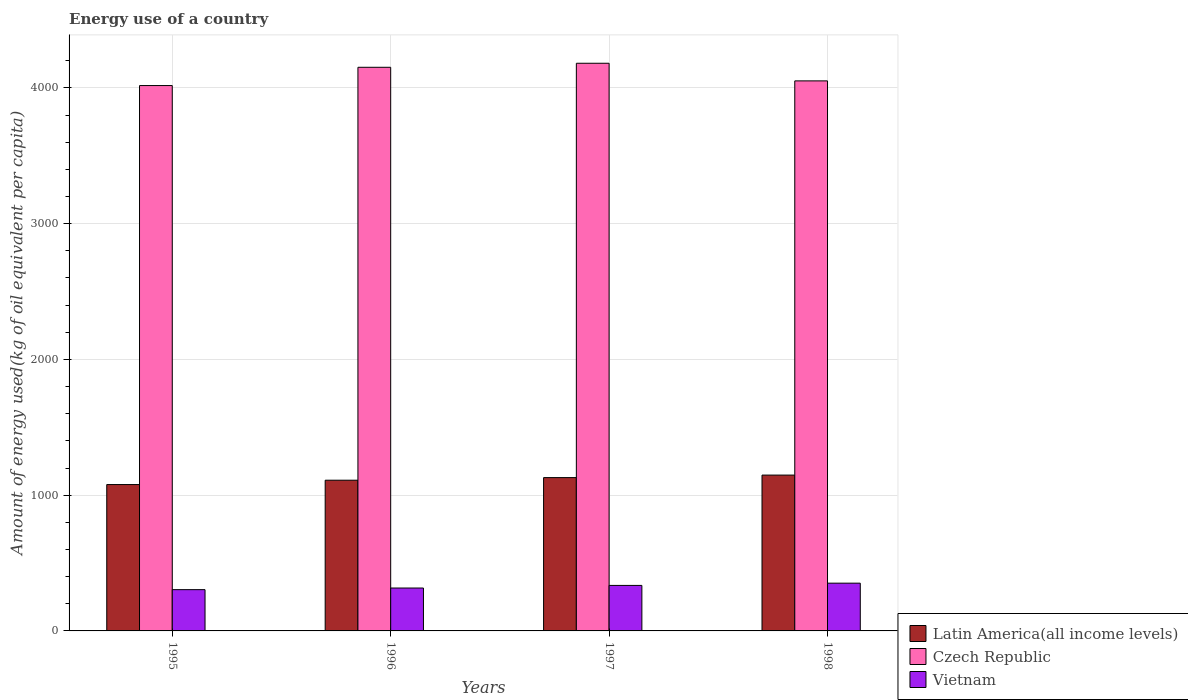How many different coloured bars are there?
Offer a very short reply. 3. Are the number of bars on each tick of the X-axis equal?
Make the answer very short. Yes. What is the label of the 4th group of bars from the left?
Keep it short and to the point. 1998. In how many cases, is the number of bars for a given year not equal to the number of legend labels?
Give a very brief answer. 0. What is the amount of energy used in in Latin America(all income levels) in 1996?
Give a very brief answer. 1110.09. Across all years, what is the maximum amount of energy used in in Czech Republic?
Provide a succinct answer. 4181.19. Across all years, what is the minimum amount of energy used in in Latin America(all income levels)?
Offer a very short reply. 1078.08. In which year was the amount of energy used in in Czech Republic maximum?
Keep it short and to the point. 1997. What is the total amount of energy used in in Vietnam in the graph?
Provide a short and direct response. 1306.82. What is the difference between the amount of energy used in in Vietnam in 1996 and that in 1998?
Give a very brief answer. -35.82. What is the difference between the amount of energy used in in Czech Republic in 1997 and the amount of energy used in in Latin America(all income levels) in 1996?
Provide a short and direct response. 3071.1. What is the average amount of energy used in in Czech Republic per year?
Ensure brevity in your answer.  4100.27. In the year 1996, what is the difference between the amount of energy used in in Vietnam and amount of energy used in in Latin America(all income levels)?
Provide a succinct answer. -794.17. What is the ratio of the amount of energy used in in Latin America(all income levels) in 1996 to that in 1997?
Your answer should be compact. 0.98. Is the amount of energy used in in Vietnam in 1997 less than that in 1998?
Make the answer very short. Yes. Is the difference between the amount of energy used in in Vietnam in 1995 and 1998 greater than the difference between the amount of energy used in in Latin America(all income levels) in 1995 and 1998?
Ensure brevity in your answer.  Yes. What is the difference between the highest and the second highest amount of energy used in in Vietnam?
Ensure brevity in your answer.  16.57. What is the difference between the highest and the lowest amount of energy used in in Czech Republic?
Your answer should be very brief. 164.22. Is the sum of the amount of energy used in in Czech Republic in 1995 and 1997 greater than the maximum amount of energy used in in Vietnam across all years?
Offer a terse response. Yes. What does the 1st bar from the left in 1997 represents?
Ensure brevity in your answer.  Latin America(all income levels). What does the 1st bar from the right in 1997 represents?
Your response must be concise. Vietnam. Are all the bars in the graph horizontal?
Ensure brevity in your answer.  No. How many years are there in the graph?
Your answer should be compact. 4. Are the values on the major ticks of Y-axis written in scientific E-notation?
Keep it short and to the point. No. Does the graph contain grids?
Ensure brevity in your answer.  Yes. Where does the legend appear in the graph?
Offer a very short reply. Bottom right. How many legend labels are there?
Make the answer very short. 3. What is the title of the graph?
Your answer should be very brief. Energy use of a country. Does "Latvia" appear as one of the legend labels in the graph?
Make the answer very short. No. What is the label or title of the Y-axis?
Offer a very short reply. Amount of energy used(kg of oil equivalent per capita). What is the Amount of energy used(kg of oil equivalent per capita) in Latin America(all income levels) in 1995?
Provide a short and direct response. 1078.08. What is the Amount of energy used(kg of oil equivalent per capita) of Czech Republic in 1995?
Give a very brief answer. 4016.97. What is the Amount of energy used(kg of oil equivalent per capita) of Vietnam in 1995?
Provide a succinct answer. 303.98. What is the Amount of energy used(kg of oil equivalent per capita) in Latin America(all income levels) in 1996?
Offer a very short reply. 1110.09. What is the Amount of energy used(kg of oil equivalent per capita) in Czech Republic in 1996?
Offer a terse response. 4151.5. What is the Amount of energy used(kg of oil equivalent per capita) of Vietnam in 1996?
Your answer should be very brief. 315.93. What is the Amount of energy used(kg of oil equivalent per capita) in Latin America(all income levels) in 1997?
Offer a very short reply. 1129.26. What is the Amount of energy used(kg of oil equivalent per capita) of Czech Republic in 1997?
Offer a very short reply. 4181.19. What is the Amount of energy used(kg of oil equivalent per capita) in Vietnam in 1997?
Keep it short and to the point. 335.17. What is the Amount of energy used(kg of oil equivalent per capita) of Latin America(all income levels) in 1998?
Ensure brevity in your answer.  1147.8. What is the Amount of energy used(kg of oil equivalent per capita) of Czech Republic in 1998?
Your response must be concise. 4051.41. What is the Amount of energy used(kg of oil equivalent per capita) of Vietnam in 1998?
Make the answer very short. 351.75. Across all years, what is the maximum Amount of energy used(kg of oil equivalent per capita) in Latin America(all income levels)?
Give a very brief answer. 1147.8. Across all years, what is the maximum Amount of energy used(kg of oil equivalent per capita) in Czech Republic?
Offer a terse response. 4181.19. Across all years, what is the maximum Amount of energy used(kg of oil equivalent per capita) in Vietnam?
Your response must be concise. 351.75. Across all years, what is the minimum Amount of energy used(kg of oil equivalent per capita) of Latin America(all income levels)?
Provide a succinct answer. 1078.08. Across all years, what is the minimum Amount of energy used(kg of oil equivalent per capita) in Czech Republic?
Your response must be concise. 4016.97. Across all years, what is the minimum Amount of energy used(kg of oil equivalent per capita) in Vietnam?
Your answer should be compact. 303.98. What is the total Amount of energy used(kg of oil equivalent per capita) in Latin America(all income levels) in the graph?
Provide a short and direct response. 4465.23. What is the total Amount of energy used(kg of oil equivalent per capita) of Czech Republic in the graph?
Ensure brevity in your answer.  1.64e+04. What is the total Amount of energy used(kg of oil equivalent per capita) in Vietnam in the graph?
Ensure brevity in your answer.  1306.82. What is the difference between the Amount of energy used(kg of oil equivalent per capita) of Latin America(all income levels) in 1995 and that in 1996?
Make the answer very short. -32.02. What is the difference between the Amount of energy used(kg of oil equivalent per capita) in Czech Republic in 1995 and that in 1996?
Your answer should be very brief. -134.53. What is the difference between the Amount of energy used(kg of oil equivalent per capita) of Vietnam in 1995 and that in 1996?
Offer a terse response. -11.95. What is the difference between the Amount of energy used(kg of oil equivalent per capita) of Latin America(all income levels) in 1995 and that in 1997?
Ensure brevity in your answer.  -51.19. What is the difference between the Amount of energy used(kg of oil equivalent per capita) in Czech Republic in 1995 and that in 1997?
Provide a short and direct response. -164.22. What is the difference between the Amount of energy used(kg of oil equivalent per capita) in Vietnam in 1995 and that in 1997?
Make the answer very short. -31.19. What is the difference between the Amount of energy used(kg of oil equivalent per capita) of Latin America(all income levels) in 1995 and that in 1998?
Your answer should be very brief. -69.72. What is the difference between the Amount of energy used(kg of oil equivalent per capita) in Czech Republic in 1995 and that in 1998?
Keep it short and to the point. -34.44. What is the difference between the Amount of energy used(kg of oil equivalent per capita) of Vietnam in 1995 and that in 1998?
Offer a very short reply. -47.76. What is the difference between the Amount of energy used(kg of oil equivalent per capita) of Latin America(all income levels) in 1996 and that in 1997?
Give a very brief answer. -19.17. What is the difference between the Amount of energy used(kg of oil equivalent per capita) in Czech Republic in 1996 and that in 1997?
Keep it short and to the point. -29.69. What is the difference between the Amount of energy used(kg of oil equivalent per capita) in Vietnam in 1996 and that in 1997?
Your answer should be compact. -19.24. What is the difference between the Amount of energy used(kg of oil equivalent per capita) of Latin America(all income levels) in 1996 and that in 1998?
Ensure brevity in your answer.  -37.7. What is the difference between the Amount of energy used(kg of oil equivalent per capita) in Czech Republic in 1996 and that in 1998?
Keep it short and to the point. 100.09. What is the difference between the Amount of energy used(kg of oil equivalent per capita) of Vietnam in 1996 and that in 1998?
Offer a terse response. -35.82. What is the difference between the Amount of energy used(kg of oil equivalent per capita) of Latin America(all income levels) in 1997 and that in 1998?
Offer a very short reply. -18.53. What is the difference between the Amount of energy used(kg of oil equivalent per capita) in Czech Republic in 1997 and that in 1998?
Provide a succinct answer. 129.78. What is the difference between the Amount of energy used(kg of oil equivalent per capita) of Vietnam in 1997 and that in 1998?
Your answer should be compact. -16.57. What is the difference between the Amount of energy used(kg of oil equivalent per capita) of Latin America(all income levels) in 1995 and the Amount of energy used(kg of oil equivalent per capita) of Czech Republic in 1996?
Keep it short and to the point. -3073.42. What is the difference between the Amount of energy used(kg of oil equivalent per capita) in Latin America(all income levels) in 1995 and the Amount of energy used(kg of oil equivalent per capita) in Vietnam in 1996?
Offer a terse response. 762.15. What is the difference between the Amount of energy used(kg of oil equivalent per capita) in Czech Republic in 1995 and the Amount of energy used(kg of oil equivalent per capita) in Vietnam in 1996?
Your answer should be very brief. 3701.05. What is the difference between the Amount of energy used(kg of oil equivalent per capita) of Latin America(all income levels) in 1995 and the Amount of energy used(kg of oil equivalent per capita) of Czech Republic in 1997?
Provide a succinct answer. -3103.11. What is the difference between the Amount of energy used(kg of oil equivalent per capita) of Latin America(all income levels) in 1995 and the Amount of energy used(kg of oil equivalent per capita) of Vietnam in 1997?
Offer a terse response. 742.91. What is the difference between the Amount of energy used(kg of oil equivalent per capita) of Czech Republic in 1995 and the Amount of energy used(kg of oil equivalent per capita) of Vietnam in 1997?
Give a very brief answer. 3681.8. What is the difference between the Amount of energy used(kg of oil equivalent per capita) of Latin America(all income levels) in 1995 and the Amount of energy used(kg of oil equivalent per capita) of Czech Republic in 1998?
Keep it short and to the point. -2973.34. What is the difference between the Amount of energy used(kg of oil equivalent per capita) in Latin America(all income levels) in 1995 and the Amount of energy used(kg of oil equivalent per capita) in Vietnam in 1998?
Ensure brevity in your answer.  726.33. What is the difference between the Amount of energy used(kg of oil equivalent per capita) of Czech Republic in 1995 and the Amount of energy used(kg of oil equivalent per capita) of Vietnam in 1998?
Provide a succinct answer. 3665.23. What is the difference between the Amount of energy used(kg of oil equivalent per capita) of Latin America(all income levels) in 1996 and the Amount of energy used(kg of oil equivalent per capita) of Czech Republic in 1997?
Your response must be concise. -3071.1. What is the difference between the Amount of energy used(kg of oil equivalent per capita) in Latin America(all income levels) in 1996 and the Amount of energy used(kg of oil equivalent per capita) in Vietnam in 1997?
Keep it short and to the point. 774.92. What is the difference between the Amount of energy used(kg of oil equivalent per capita) in Czech Republic in 1996 and the Amount of energy used(kg of oil equivalent per capita) in Vietnam in 1997?
Offer a terse response. 3816.33. What is the difference between the Amount of energy used(kg of oil equivalent per capita) in Latin America(all income levels) in 1996 and the Amount of energy used(kg of oil equivalent per capita) in Czech Republic in 1998?
Your response must be concise. -2941.32. What is the difference between the Amount of energy used(kg of oil equivalent per capita) in Latin America(all income levels) in 1996 and the Amount of energy used(kg of oil equivalent per capita) in Vietnam in 1998?
Offer a very short reply. 758.35. What is the difference between the Amount of energy used(kg of oil equivalent per capita) in Czech Republic in 1996 and the Amount of energy used(kg of oil equivalent per capita) in Vietnam in 1998?
Offer a terse response. 3799.76. What is the difference between the Amount of energy used(kg of oil equivalent per capita) in Latin America(all income levels) in 1997 and the Amount of energy used(kg of oil equivalent per capita) in Czech Republic in 1998?
Provide a short and direct response. -2922.15. What is the difference between the Amount of energy used(kg of oil equivalent per capita) of Latin America(all income levels) in 1997 and the Amount of energy used(kg of oil equivalent per capita) of Vietnam in 1998?
Give a very brief answer. 777.52. What is the difference between the Amount of energy used(kg of oil equivalent per capita) of Czech Republic in 1997 and the Amount of energy used(kg of oil equivalent per capita) of Vietnam in 1998?
Make the answer very short. 3829.45. What is the average Amount of energy used(kg of oil equivalent per capita) of Latin America(all income levels) per year?
Provide a succinct answer. 1116.31. What is the average Amount of energy used(kg of oil equivalent per capita) of Czech Republic per year?
Offer a terse response. 4100.27. What is the average Amount of energy used(kg of oil equivalent per capita) in Vietnam per year?
Your response must be concise. 326.71. In the year 1995, what is the difference between the Amount of energy used(kg of oil equivalent per capita) of Latin America(all income levels) and Amount of energy used(kg of oil equivalent per capita) of Czech Republic?
Offer a very short reply. -2938.9. In the year 1995, what is the difference between the Amount of energy used(kg of oil equivalent per capita) of Latin America(all income levels) and Amount of energy used(kg of oil equivalent per capita) of Vietnam?
Your response must be concise. 774.1. In the year 1995, what is the difference between the Amount of energy used(kg of oil equivalent per capita) of Czech Republic and Amount of energy used(kg of oil equivalent per capita) of Vietnam?
Your answer should be compact. 3712.99. In the year 1996, what is the difference between the Amount of energy used(kg of oil equivalent per capita) of Latin America(all income levels) and Amount of energy used(kg of oil equivalent per capita) of Czech Republic?
Provide a succinct answer. -3041.41. In the year 1996, what is the difference between the Amount of energy used(kg of oil equivalent per capita) in Latin America(all income levels) and Amount of energy used(kg of oil equivalent per capita) in Vietnam?
Provide a succinct answer. 794.17. In the year 1996, what is the difference between the Amount of energy used(kg of oil equivalent per capita) in Czech Republic and Amount of energy used(kg of oil equivalent per capita) in Vietnam?
Offer a very short reply. 3835.57. In the year 1997, what is the difference between the Amount of energy used(kg of oil equivalent per capita) in Latin America(all income levels) and Amount of energy used(kg of oil equivalent per capita) in Czech Republic?
Ensure brevity in your answer.  -3051.93. In the year 1997, what is the difference between the Amount of energy used(kg of oil equivalent per capita) of Latin America(all income levels) and Amount of energy used(kg of oil equivalent per capita) of Vietnam?
Make the answer very short. 794.09. In the year 1997, what is the difference between the Amount of energy used(kg of oil equivalent per capita) of Czech Republic and Amount of energy used(kg of oil equivalent per capita) of Vietnam?
Offer a terse response. 3846.02. In the year 1998, what is the difference between the Amount of energy used(kg of oil equivalent per capita) in Latin America(all income levels) and Amount of energy used(kg of oil equivalent per capita) in Czech Republic?
Your response must be concise. -2903.62. In the year 1998, what is the difference between the Amount of energy used(kg of oil equivalent per capita) in Latin America(all income levels) and Amount of energy used(kg of oil equivalent per capita) in Vietnam?
Provide a short and direct response. 796.05. In the year 1998, what is the difference between the Amount of energy used(kg of oil equivalent per capita) in Czech Republic and Amount of energy used(kg of oil equivalent per capita) in Vietnam?
Ensure brevity in your answer.  3699.67. What is the ratio of the Amount of energy used(kg of oil equivalent per capita) of Latin America(all income levels) in 1995 to that in 1996?
Offer a very short reply. 0.97. What is the ratio of the Amount of energy used(kg of oil equivalent per capita) in Czech Republic in 1995 to that in 1996?
Offer a very short reply. 0.97. What is the ratio of the Amount of energy used(kg of oil equivalent per capita) of Vietnam in 1995 to that in 1996?
Ensure brevity in your answer.  0.96. What is the ratio of the Amount of energy used(kg of oil equivalent per capita) in Latin America(all income levels) in 1995 to that in 1997?
Provide a short and direct response. 0.95. What is the ratio of the Amount of energy used(kg of oil equivalent per capita) in Czech Republic in 1995 to that in 1997?
Give a very brief answer. 0.96. What is the ratio of the Amount of energy used(kg of oil equivalent per capita) in Vietnam in 1995 to that in 1997?
Provide a succinct answer. 0.91. What is the ratio of the Amount of energy used(kg of oil equivalent per capita) of Latin America(all income levels) in 1995 to that in 1998?
Your answer should be compact. 0.94. What is the ratio of the Amount of energy used(kg of oil equivalent per capita) of Vietnam in 1995 to that in 1998?
Your answer should be very brief. 0.86. What is the ratio of the Amount of energy used(kg of oil equivalent per capita) in Czech Republic in 1996 to that in 1997?
Make the answer very short. 0.99. What is the ratio of the Amount of energy used(kg of oil equivalent per capita) of Vietnam in 1996 to that in 1997?
Offer a very short reply. 0.94. What is the ratio of the Amount of energy used(kg of oil equivalent per capita) of Latin America(all income levels) in 1996 to that in 1998?
Offer a very short reply. 0.97. What is the ratio of the Amount of energy used(kg of oil equivalent per capita) of Czech Republic in 1996 to that in 1998?
Ensure brevity in your answer.  1.02. What is the ratio of the Amount of energy used(kg of oil equivalent per capita) in Vietnam in 1996 to that in 1998?
Provide a short and direct response. 0.9. What is the ratio of the Amount of energy used(kg of oil equivalent per capita) of Latin America(all income levels) in 1997 to that in 1998?
Offer a very short reply. 0.98. What is the ratio of the Amount of energy used(kg of oil equivalent per capita) of Czech Republic in 1997 to that in 1998?
Offer a terse response. 1.03. What is the ratio of the Amount of energy used(kg of oil equivalent per capita) of Vietnam in 1997 to that in 1998?
Provide a short and direct response. 0.95. What is the difference between the highest and the second highest Amount of energy used(kg of oil equivalent per capita) of Latin America(all income levels)?
Offer a very short reply. 18.53. What is the difference between the highest and the second highest Amount of energy used(kg of oil equivalent per capita) in Czech Republic?
Ensure brevity in your answer.  29.69. What is the difference between the highest and the second highest Amount of energy used(kg of oil equivalent per capita) in Vietnam?
Make the answer very short. 16.57. What is the difference between the highest and the lowest Amount of energy used(kg of oil equivalent per capita) in Latin America(all income levels)?
Offer a terse response. 69.72. What is the difference between the highest and the lowest Amount of energy used(kg of oil equivalent per capita) in Czech Republic?
Provide a succinct answer. 164.22. What is the difference between the highest and the lowest Amount of energy used(kg of oil equivalent per capita) in Vietnam?
Your answer should be compact. 47.76. 